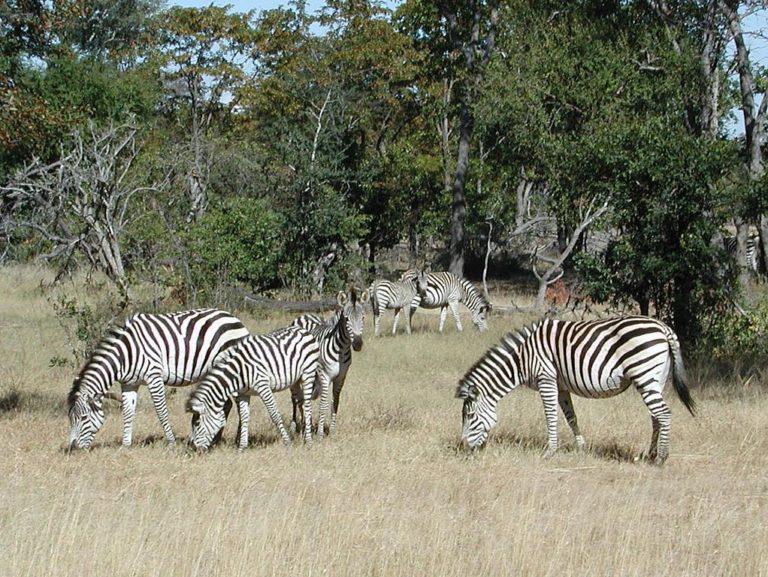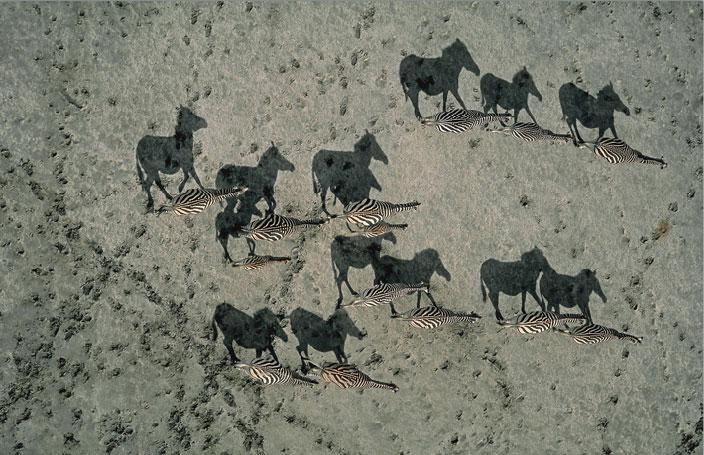The first image is the image on the left, the second image is the image on the right. For the images displayed, is the sentence "In one of the images the zebras are all walking in the same direction." factually correct? Answer yes or no. Yes. The first image is the image on the left, the second image is the image on the right. Given the left and right images, does the statement "One image shows zebras standing around grazing, and the other shows zebras that are all walking in one direction." hold true? Answer yes or no. Yes. 